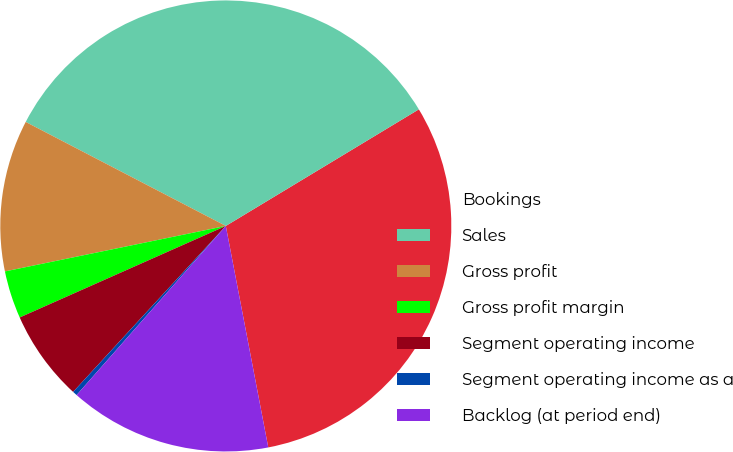<chart> <loc_0><loc_0><loc_500><loc_500><pie_chart><fcel>Bookings<fcel>Sales<fcel>Gross profit<fcel>Gross profit margin<fcel>Segment operating income<fcel>Segment operating income as a<fcel>Backlog (at period end)<nl><fcel>30.63%<fcel>33.72%<fcel>10.86%<fcel>3.42%<fcel>6.51%<fcel>0.33%<fcel>14.52%<nl></chart> 